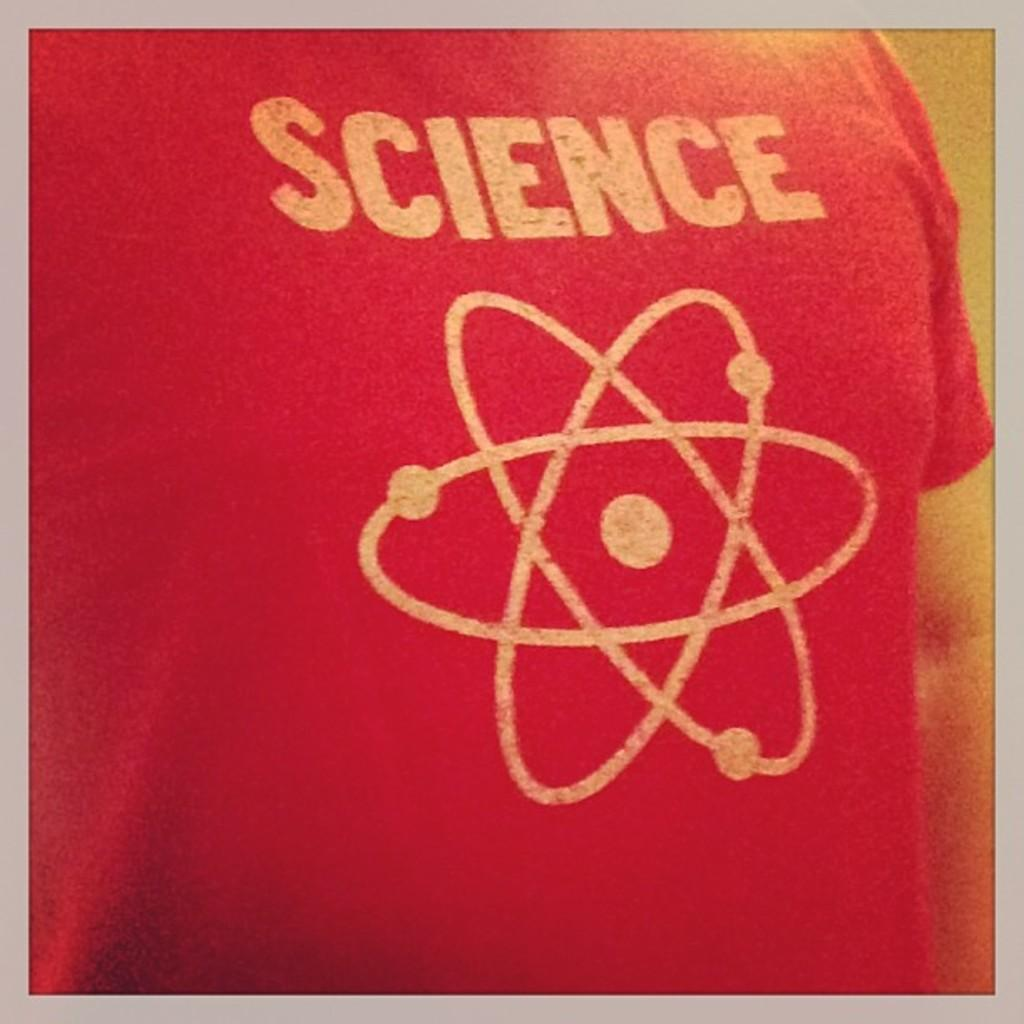<image>
Write a terse but informative summary of the picture. A red shirt with the word SCIENCE on the back 